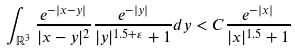Convert formula to latex. <formula><loc_0><loc_0><loc_500><loc_500>\int _ { \mathbb { R } ^ { 3 } } \frac { e ^ { - | x - y | } } { | x - y | ^ { 2 } } \frac { e ^ { - | y | } } { | y | ^ { 1 . 5 + \varepsilon } + 1 } d y < C \frac { e ^ { - | x | } } { | x | ^ { 1 . 5 } + 1 }</formula> 